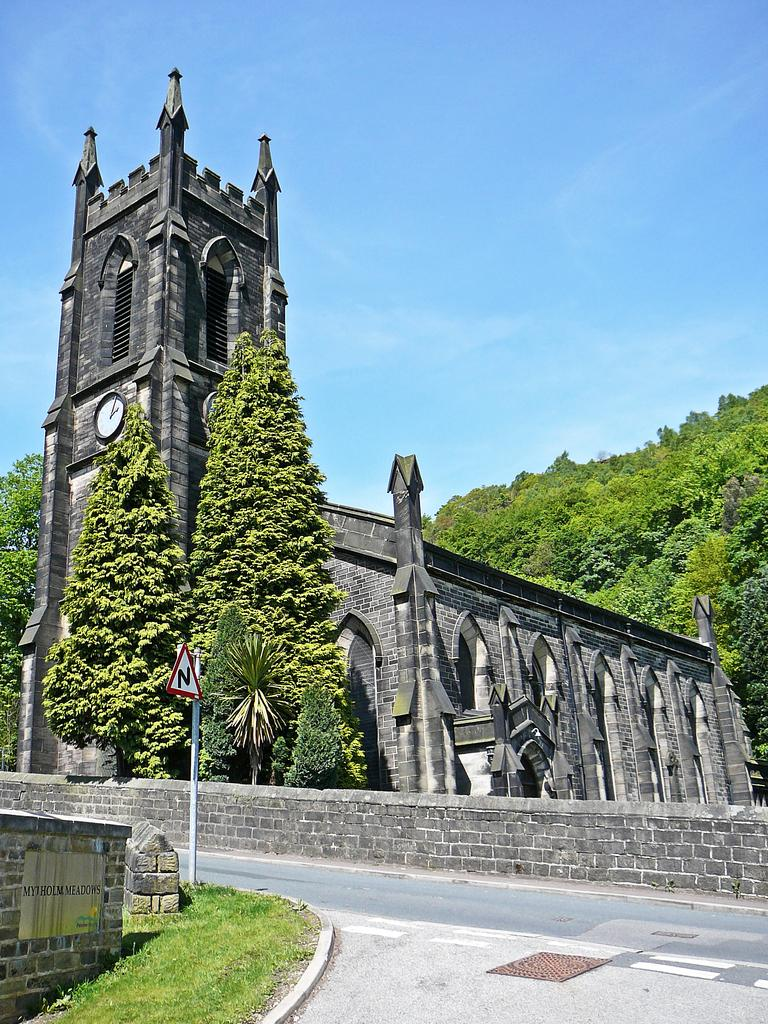What is the main structure in the image? There is a building with a clock in the image. What is in front of the building? There is a wall and a sign board in front of the building. What is the setting of the image? There is a road, trees, and grass in the image. What can be seen in the sky? The sky is visible in the image. How many hands are holding the sign board in the image? There are no hands holding the sign board in the image, as it is a stationary object. Can you tell me how many sisters are standing next to the trees in the image? There are no people, including sisters, present in the image; it only features a building, wall, sign board, road, trees, grass, and sky. 